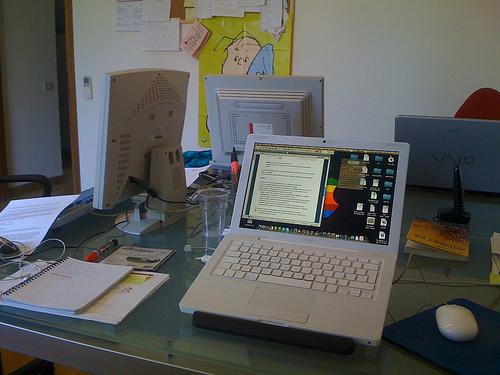Enumerate any three noteworthy pieces of equipment in the picture. A grey laptop in the background, a peanuts poster of Linus, and a blue computer table are among the noteworthy items in the image. Describe any two contrasting items from the image. The image features a red marker placed near a blue computer table, and a green poster behind a white monitor. Detail the pair of items found in the image that are placed nearby each other. A white laptop with a document open on its screen is placed next to two monitors; and a white mouse can be seen on a black mousepad. Write about the computer peripherals displayed in the image. The image shows a white mouse on a black mousepad, a white keyboard, a blue rectangular neoprene mousepad, and a corded white plastic computer mouse. Express the general ambiance of the setting where the image is portrayed. The image portrays a cozy workspace containing a laptop and peripherals on a table surrounded by miscellaneous items and decor. Mention the primary computer setup in the image with its peripherals. A white laptop with an open document on its screen is accompanied by a white keyboard, a white mouse on a black mousepad, and two monitors. Determine the primary electronic device and its adjacent accessories in the image. The primary electronic device is a white laptop, with accessories such as a white keyboard, white mouse, and two monitors adjacent to it. Briefly describe the organization of the workspace in this image. There is a laptop on a blue table, surrounded by a keyboard, mouse, mousepad, and two monitors, with various other items scattered around. Narrate the most prominent electronic devices showcased in the image. The image showcases a white laptop in the foreground, a silver gray apple laptop, a Sony Vaio laptop, and two white computer monitors. Explain the color theme and the primary focus of the image. The image has a predominantly white and blue theme, with the primary focus on a laptop and its peripherals arranged on a table. 